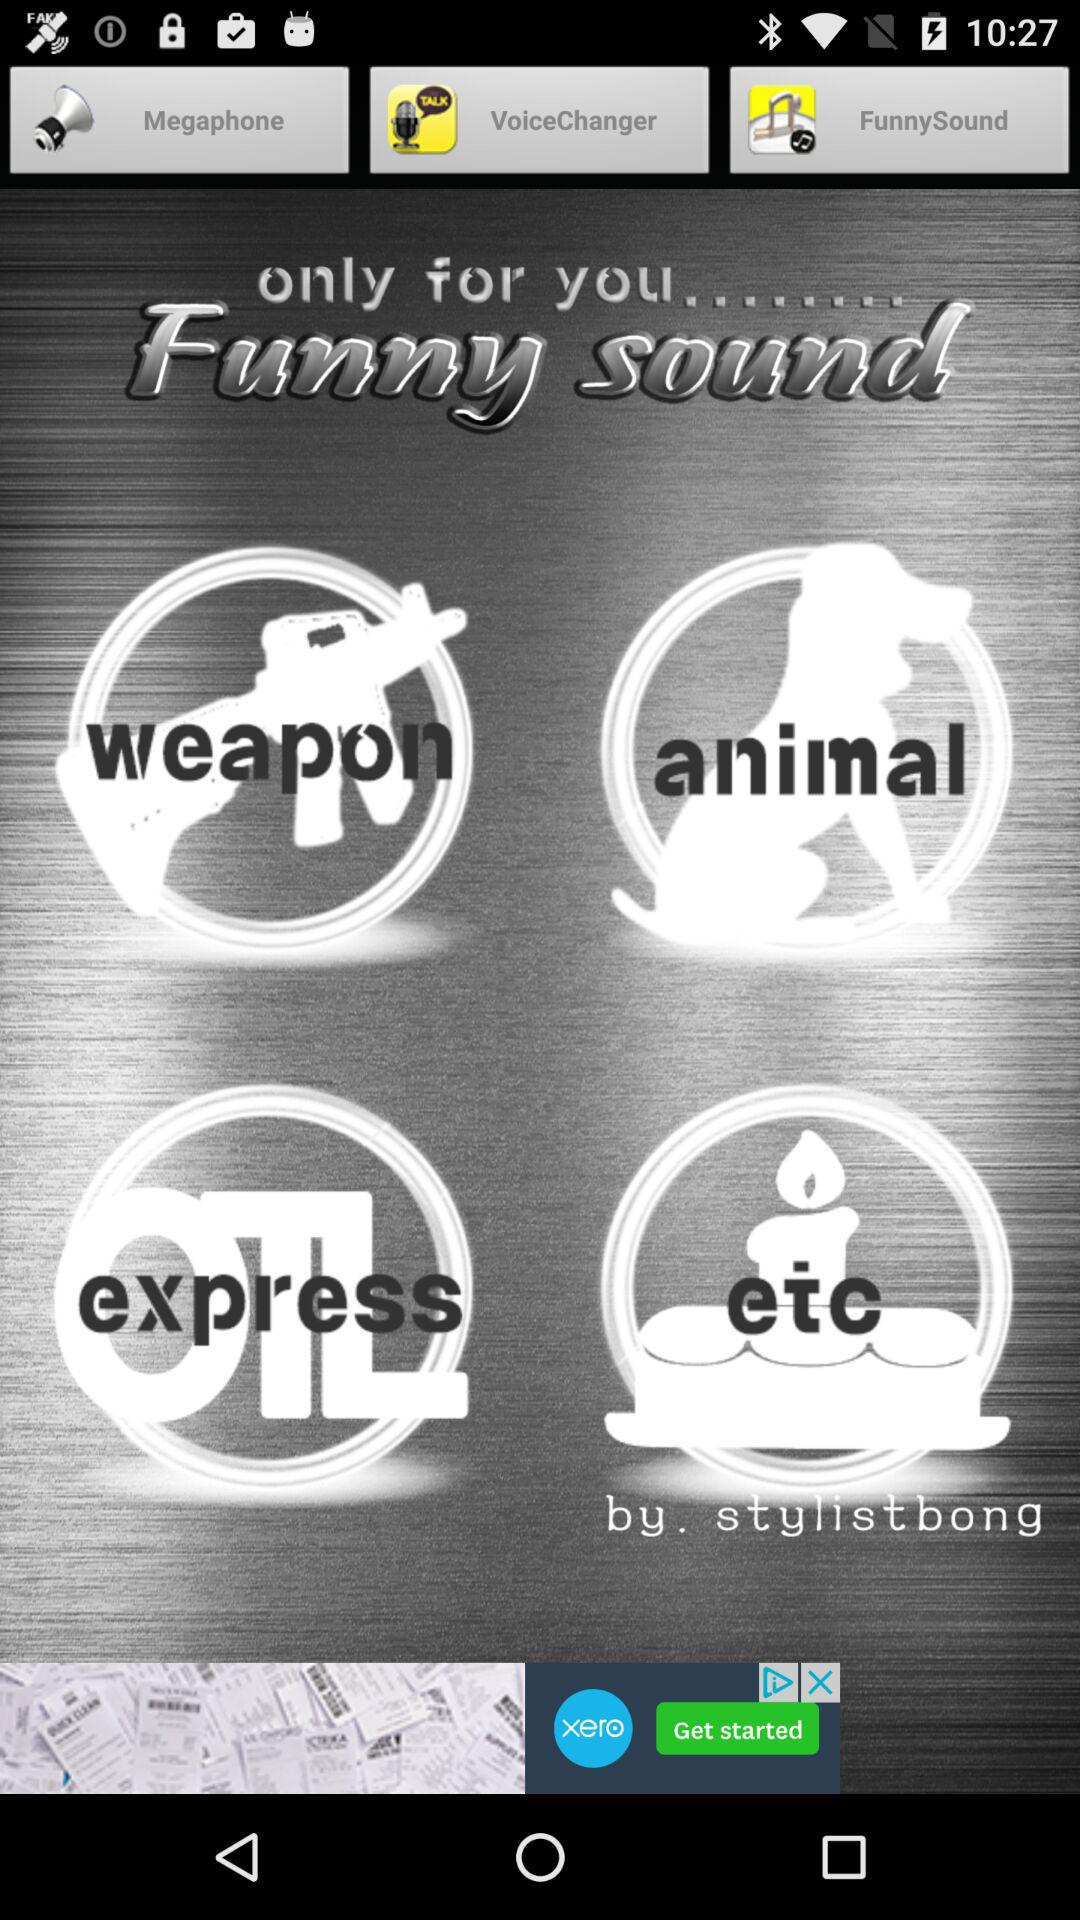What are the options available for the funny sound? The options available for the funny sound are "weapon", "animal", "express" and "etc". 